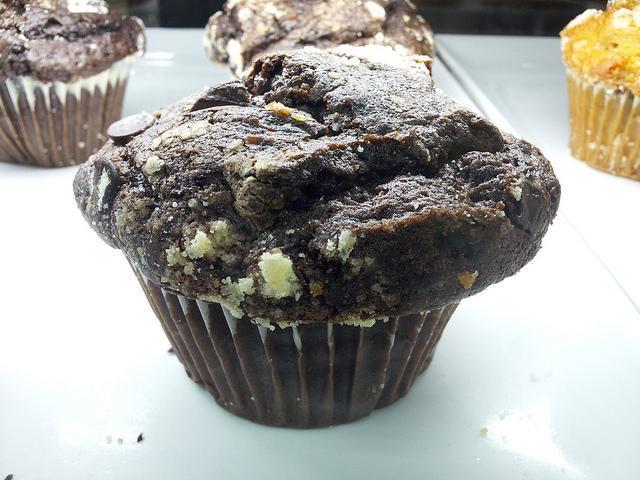How many cupcakes are there?
Give a very brief answer. 4. How many cakes are in the picture?
Give a very brief answer. 4. 